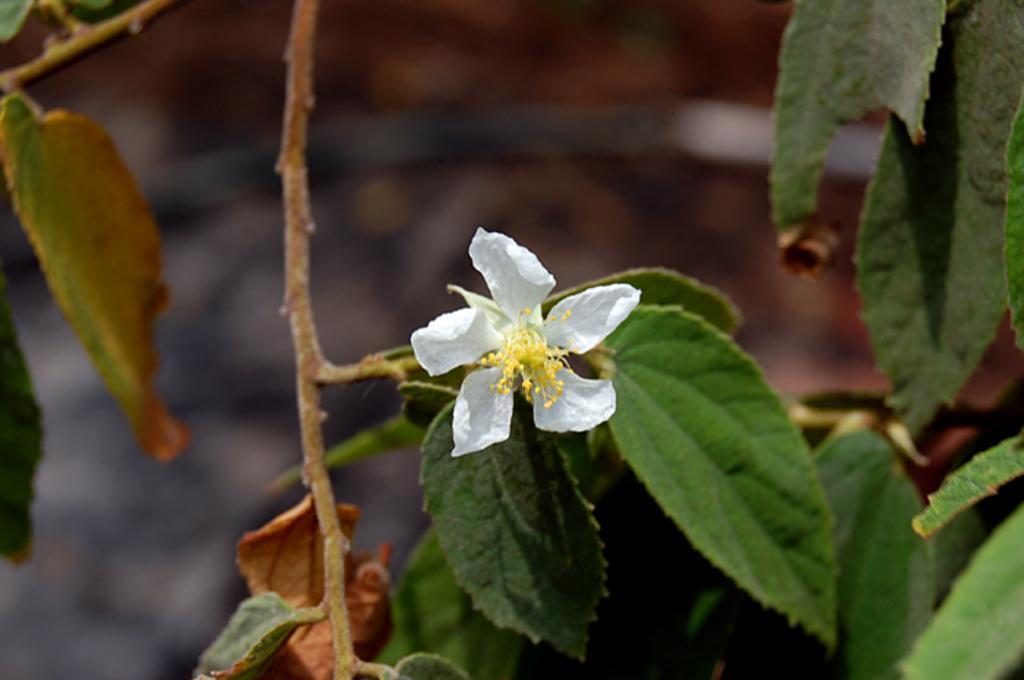In one or two sentences, can you explain what this image depicts? In the foreground of this picture, there is a flower and leaves to a stem and in the background, there is a stem and leafs. 